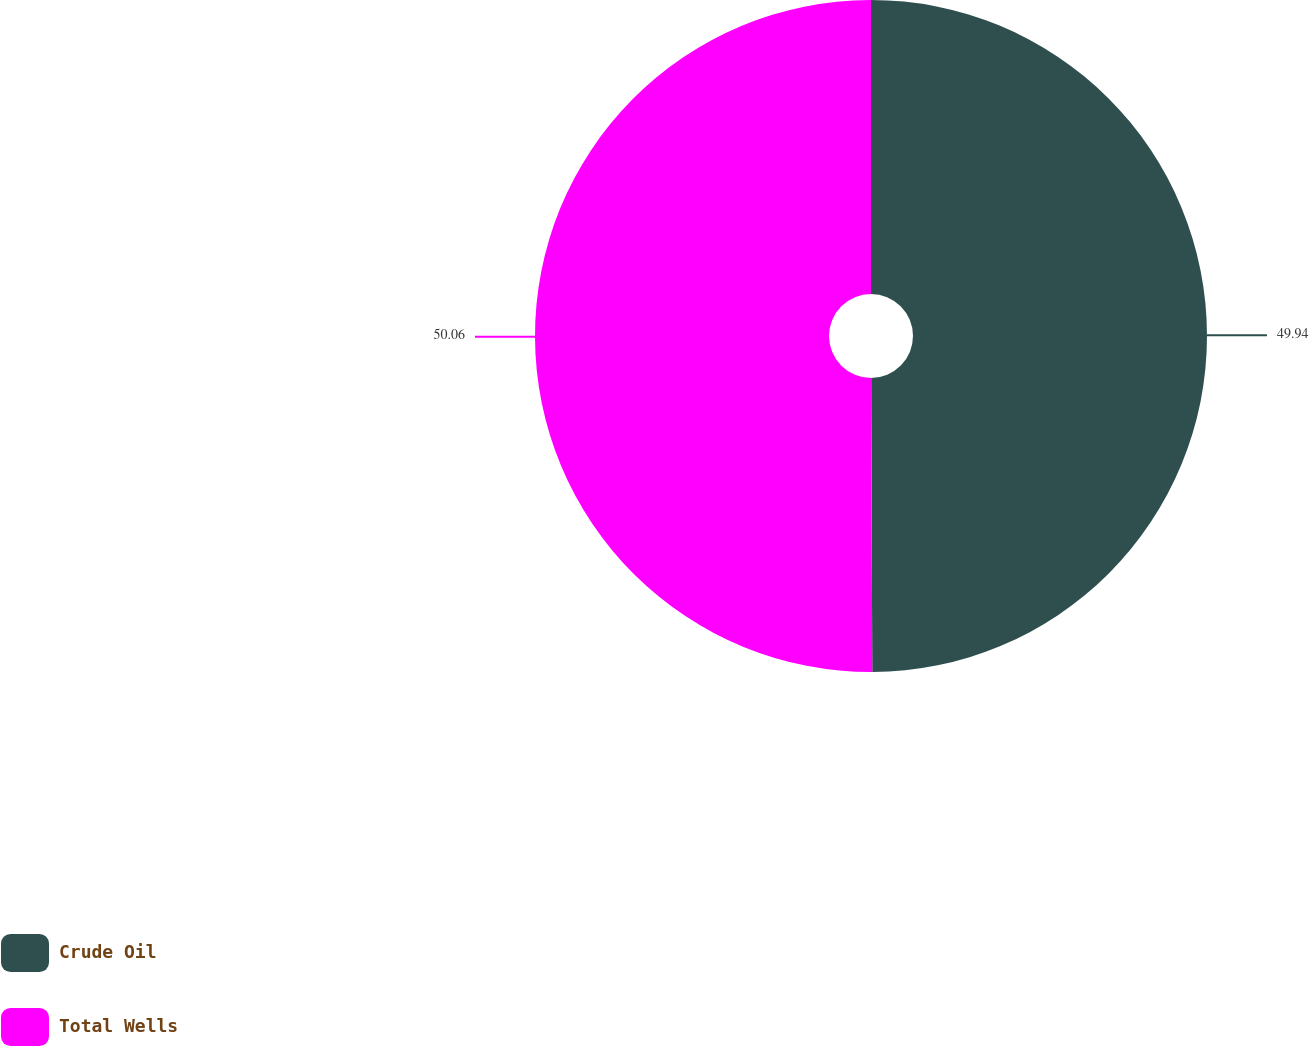<chart> <loc_0><loc_0><loc_500><loc_500><pie_chart><fcel>Crude Oil<fcel>Total Wells<nl><fcel>49.94%<fcel>50.06%<nl></chart> 